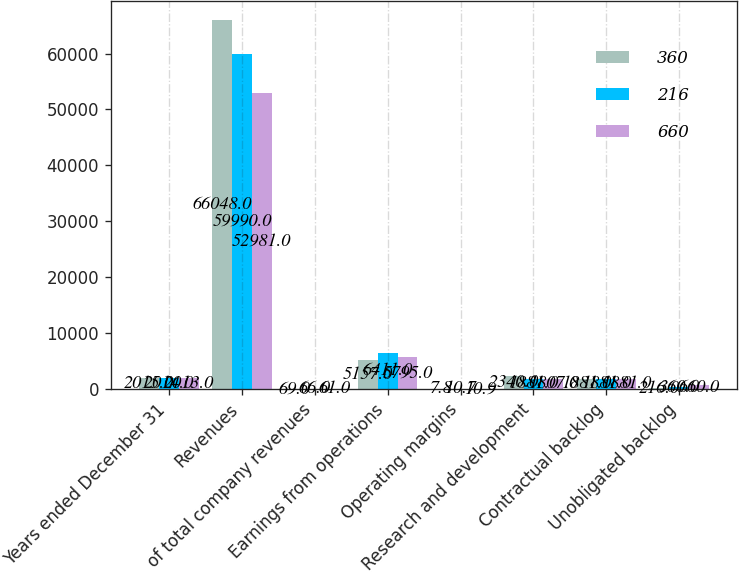<chart> <loc_0><loc_0><loc_500><loc_500><stacked_bar_chart><ecel><fcel>Years ended December 31<fcel>Revenues<fcel>of total company revenues<fcel>Earnings from operations<fcel>Operating margins<fcel>Research and development<fcel>Contractual backlog<fcel>Unobligated backlog<nl><fcel>360<fcel>2015<fcel>66048<fcel>69<fcel>5157<fcel>7.8<fcel>2340<fcel>1881<fcel>216<nl><fcel>216<fcel>2014<fcel>59990<fcel>66<fcel>6411<fcel>10.7<fcel>1881<fcel>1881<fcel>360<nl><fcel>660<fcel>2013<fcel>52981<fcel>61<fcel>5795<fcel>10.9<fcel>1807<fcel>1881<fcel>660<nl></chart> 